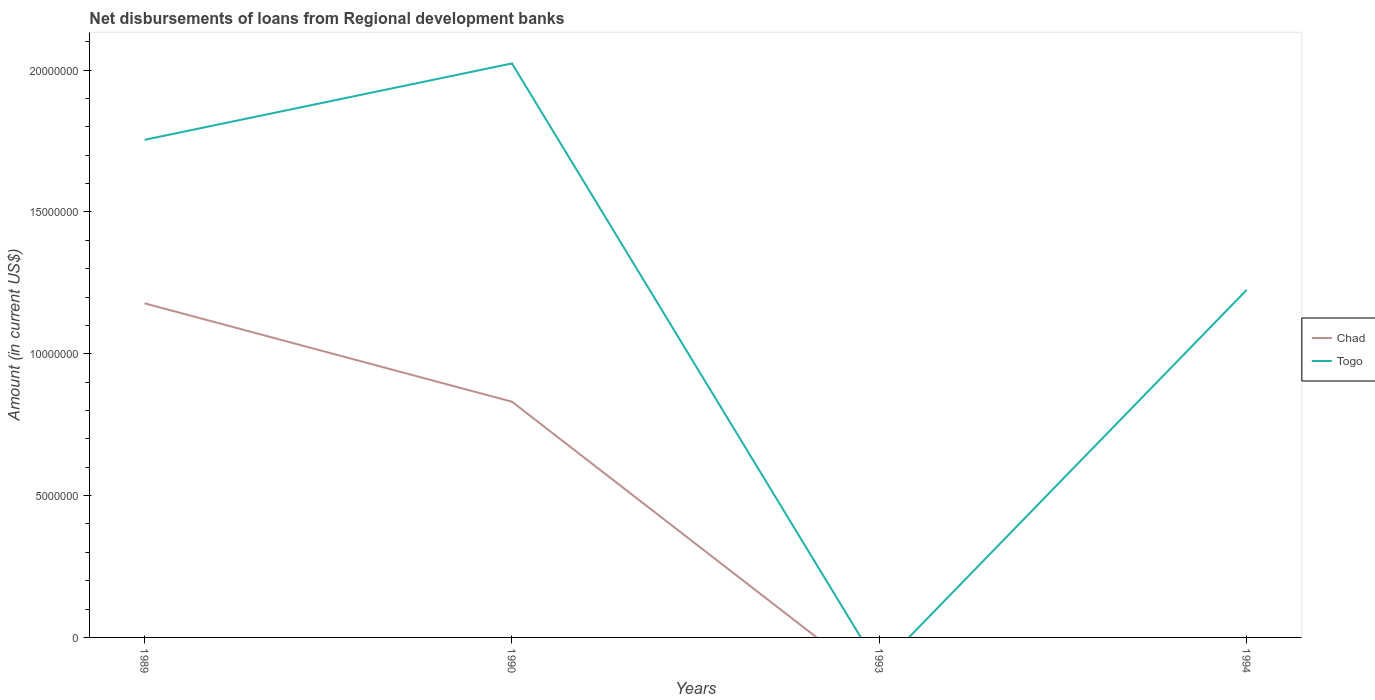How many different coloured lines are there?
Offer a terse response. 2. Does the line corresponding to Togo intersect with the line corresponding to Chad?
Your answer should be compact. No. Is the number of lines equal to the number of legend labels?
Keep it short and to the point. No. What is the total amount of disbursements of loans from regional development banks in Togo in the graph?
Provide a short and direct response. 5.29e+06. What is the difference between the highest and the second highest amount of disbursements of loans from regional development banks in Chad?
Provide a succinct answer. 1.18e+07. Is the amount of disbursements of loans from regional development banks in Chad strictly greater than the amount of disbursements of loans from regional development banks in Togo over the years?
Give a very brief answer. Yes. Where does the legend appear in the graph?
Provide a succinct answer. Center right. How many legend labels are there?
Provide a succinct answer. 2. What is the title of the graph?
Your answer should be very brief. Net disbursements of loans from Regional development banks. What is the label or title of the X-axis?
Offer a very short reply. Years. What is the label or title of the Y-axis?
Ensure brevity in your answer.  Amount (in current US$). What is the Amount (in current US$) in Chad in 1989?
Ensure brevity in your answer.  1.18e+07. What is the Amount (in current US$) of Togo in 1989?
Provide a short and direct response. 1.75e+07. What is the Amount (in current US$) of Chad in 1990?
Make the answer very short. 8.31e+06. What is the Amount (in current US$) of Togo in 1990?
Your answer should be compact. 2.02e+07. What is the Amount (in current US$) in Chad in 1994?
Give a very brief answer. 0. What is the Amount (in current US$) of Togo in 1994?
Give a very brief answer. 1.23e+07. Across all years, what is the maximum Amount (in current US$) of Chad?
Offer a very short reply. 1.18e+07. Across all years, what is the maximum Amount (in current US$) of Togo?
Your answer should be compact. 2.02e+07. Across all years, what is the minimum Amount (in current US$) of Chad?
Offer a very short reply. 0. Across all years, what is the minimum Amount (in current US$) in Togo?
Provide a succinct answer. 0. What is the total Amount (in current US$) in Chad in the graph?
Make the answer very short. 2.01e+07. What is the total Amount (in current US$) of Togo in the graph?
Your response must be concise. 5.00e+07. What is the difference between the Amount (in current US$) in Chad in 1989 and that in 1990?
Keep it short and to the point. 3.47e+06. What is the difference between the Amount (in current US$) in Togo in 1989 and that in 1990?
Offer a terse response. -2.69e+06. What is the difference between the Amount (in current US$) in Togo in 1989 and that in 1994?
Your answer should be compact. 5.29e+06. What is the difference between the Amount (in current US$) in Togo in 1990 and that in 1994?
Ensure brevity in your answer.  7.98e+06. What is the difference between the Amount (in current US$) of Chad in 1989 and the Amount (in current US$) of Togo in 1990?
Offer a terse response. -8.46e+06. What is the difference between the Amount (in current US$) in Chad in 1989 and the Amount (in current US$) in Togo in 1994?
Your answer should be very brief. -4.75e+05. What is the difference between the Amount (in current US$) of Chad in 1990 and the Amount (in current US$) of Togo in 1994?
Offer a very short reply. -3.94e+06. What is the average Amount (in current US$) in Chad per year?
Give a very brief answer. 5.02e+06. What is the average Amount (in current US$) of Togo per year?
Offer a very short reply. 1.25e+07. In the year 1989, what is the difference between the Amount (in current US$) in Chad and Amount (in current US$) in Togo?
Provide a succinct answer. -5.76e+06. In the year 1990, what is the difference between the Amount (in current US$) in Chad and Amount (in current US$) in Togo?
Offer a very short reply. -1.19e+07. What is the ratio of the Amount (in current US$) of Chad in 1989 to that in 1990?
Provide a short and direct response. 1.42. What is the ratio of the Amount (in current US$) of Togo in 1989 to that in 1990?
Your answer should be compact. 0.87. What is the ratio of the Amount (in current US$) in Togo in 1989 to that in 1994?
Ensure brevity in your answer.  1.43. What is the ratio of the Amount (in current US$) of Togo in 1990 to that in 1994?
Provide a short and direct response. 1.65. What is the difference between the highest and the second highest Amount (in current US$) in Togo?
Offer a terse response. 2.69e+06. What is the difference between the highest and the lowest Amount (in current US$) of Chad?
Your response must be concise. 1.18e+07. What is the difference between the highest and the lowest Amount (in current US$) of Togo?
Provide a short and direct response. 2.02e+07. 